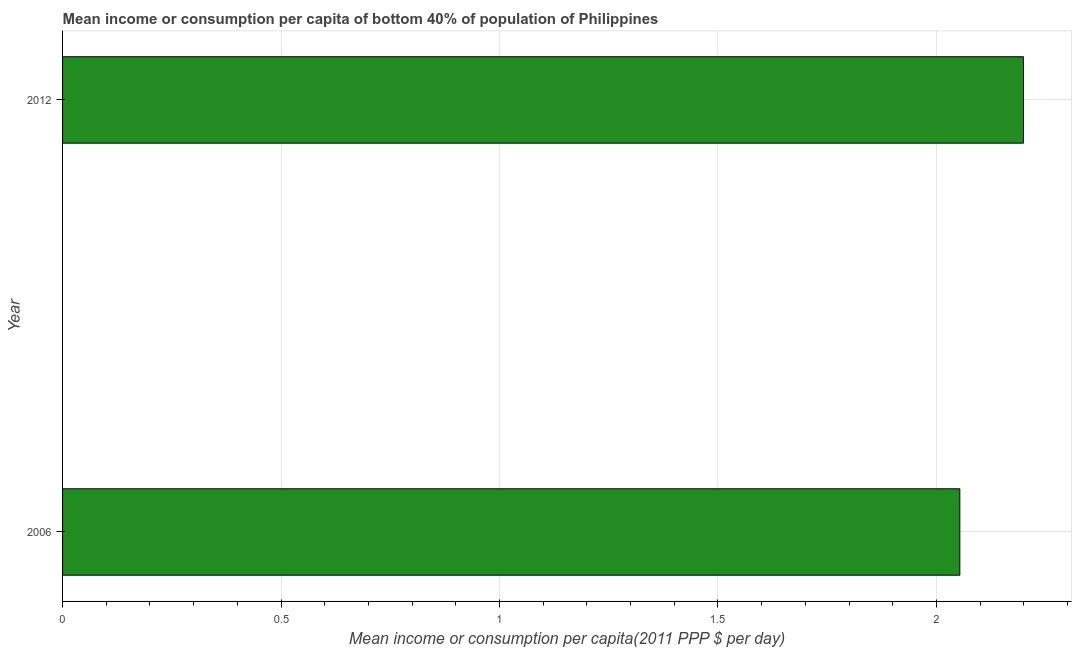Does the graph contain any zero values?
Make the answer very short. No. What is the title of the graph?
Give a very brief answer. Mean income or consumption per capita of bottom 40% of population of Philippines. What is the label or title of the X-axis?
Provide a short and direct response. Mean income or consumption per capita(2011 PPP $ per day). What is the label or title of the Y-axis?
Your answer should be very brief. Year. What is the mean income or consumption in 2012?
Your response must be concise. 2.2. Across all years, what is the maximum mean income or consumption?
Keep it short and to the point. 2.2. Across all years, what is the minimum mean income or consumption?
Provide a succinct answer. 2.05. What is the sum of the mean income or consumption?
Your answer should be very brief. 4.25. What is the difference between the mean income or consumption in 2006 and 2012?
Offer a terse response. -0.15. What is the average mean income or consumption per year?
Your answer should be compact. 2.13. What is the median mean income or consumption?
Your response must be concise. 2.13. In how many years, is the mean income or consumption greater than 1.9 $?
Your answer should be very brief. 2. Do a majority of the years between 2006 and 2012 (inclusive) have mean income or consumption greater than 0.9 $?
Your answer should be compact. Yes. What is the ratio of the mean income or consumption in 2006 to that in 2012?
Make the answer very short. 0.93. Is the mean income or consumption in 2006 less than that in 2012?
Your answer should be very brief. Yes. How many years are there in the graph?
Your response must be concise. 2. Are the values on the major ticks of X-axis written in scientific E-notation?
Offer a very short reply. No. What is the Mean income or consumption per capita(2011 PPP $ per day) in 2006?
Offer a terse response. 2.05. What is the Mean income or consumption per capita(2011 PPP $ per day) in 2012?
Ensure brevity in your answer.  2.2. What is the difference between the Mean income or consumption per capita(2011 PPP $ per day) in 2006 and 2012?
Give a very brief answer. -0.15. What is the ratio of the Mean income or consumption per capita(2011 PPP $ per day) in 2006 to that in 2012?
Make the answer very short. 0.93. 